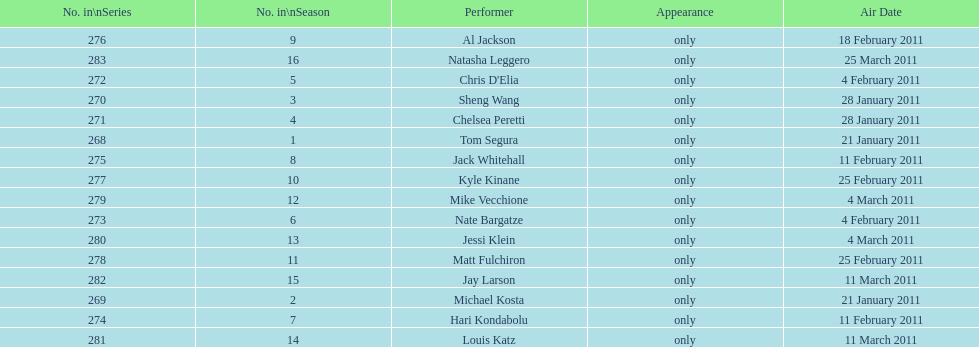What was hari's surname? Kondabolu. Give me the full table as a dictionary. {'header': ['No. in\\nSeries', 'No. in\\nSeason', 'Performer', 'Appearance', 'Air Date'], 'rows': [['276', '9', 'Al Jackson', 'only', '18 February 2011'], ['283', '16', 'Natasha Leggero', 'only', '25 March 2011'], ['272', '5', "Chris D'Elia", 'only', '4 February 2011'], ['270', '3', 'Sheng Wang', 'only', '28 January 2011'], ['271', '4', 'Chelsea Peretti', 'only', '28 January 2011'], ['268', '1', 'Tom Segura', 'only', '21 January 2011'], ['275', '8', 'Jack Whitehall', 'only', '11 February 2011'], ['277', '10', 'Kyle Kinane', 'only', '25 February 2011'], ['279', '12', 'Mike Vecchione', 'only', '4 March 2011'], ['273', '6', 'Nate Bargatze', 'only', '4 February 2011'], ['280', '13', 'Jessi Klein', 'only', '4 March 2011'], ['278', '11', 'Matt Fulchiron', 'only', '25 February 2011'], ['282', '15', 'Jay Larson', 'only', '11 March 2011'], ['269', '2', 'Michael Kosta', 'only', '21 January 2011'], ['274', '7', 'Hari Kondabolu', 'only', '11 February 2011'], ['281', '14', 'Louis Katz', 'only', '11 March 2011']]} 